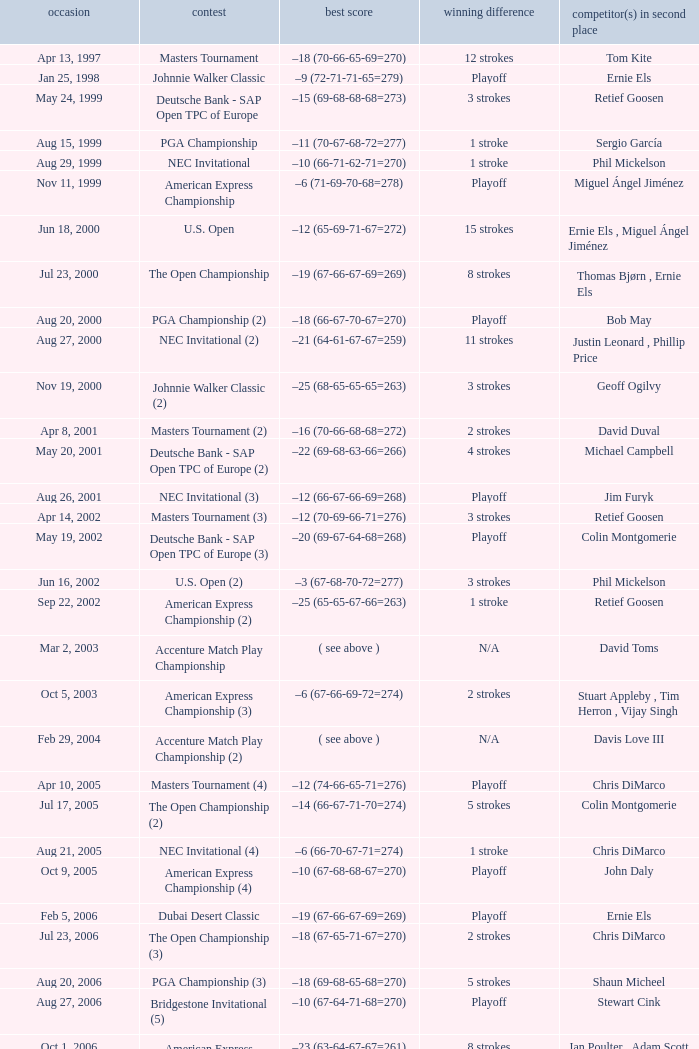Who has the Winning score of –10 (66-71-62-71=270) ? Phil Mickelson. 